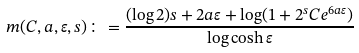Convert formula to latex. <formula><loc_0><loc_0><loc_500><loc_500>m ( C , a , \varepsilon , s ) \colon = \frac { ( \log 2 ) s + 2 a \varepsilon + \log ( 1 + 2 ^ { s } C e ^ { 6 a \varepsilon } ) } { \log \cosh \varepsilon }</formula> 